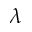Convert formula to latex. <formula><loc_0><loc_0><loc_500><loc_500>\lambda</formula> 